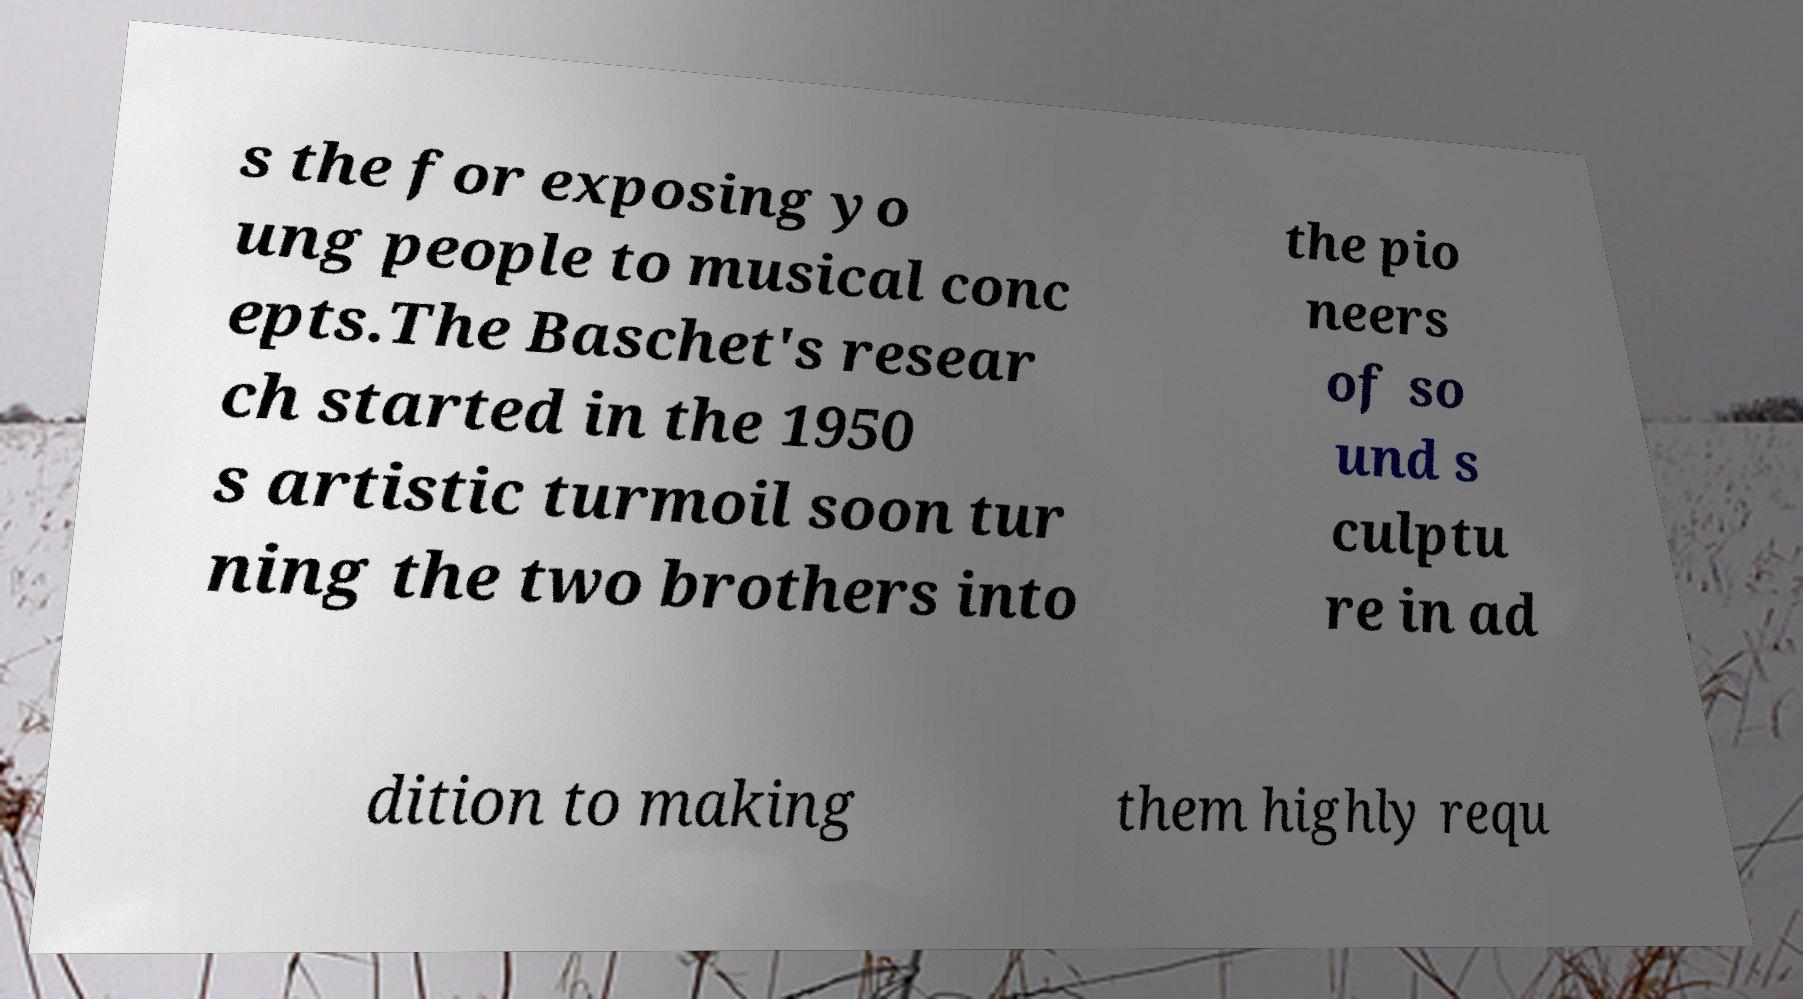For documentation purposes, I need the text within this image transcribed. Could you provide that? s the for exposing yo ung people to musical conc epts.The Baschet's resear ch started in the 1950 s artistic turmoil soon tur ning the two brothers into the pio neers of so und s culptu re in ad dition to making them highly requ 